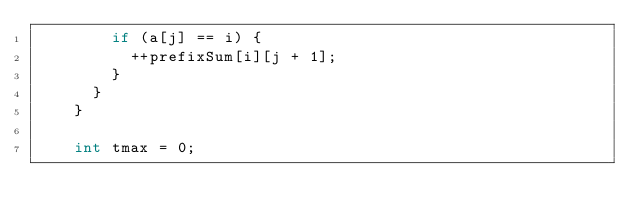<code> <loc_0><loc_0><loc_500><loc_500><_C++_>        if (a[j] == i) {
          ++prefixSum[i][j + 1];
        }
      }
    }

    int tmax = 0;</code> 